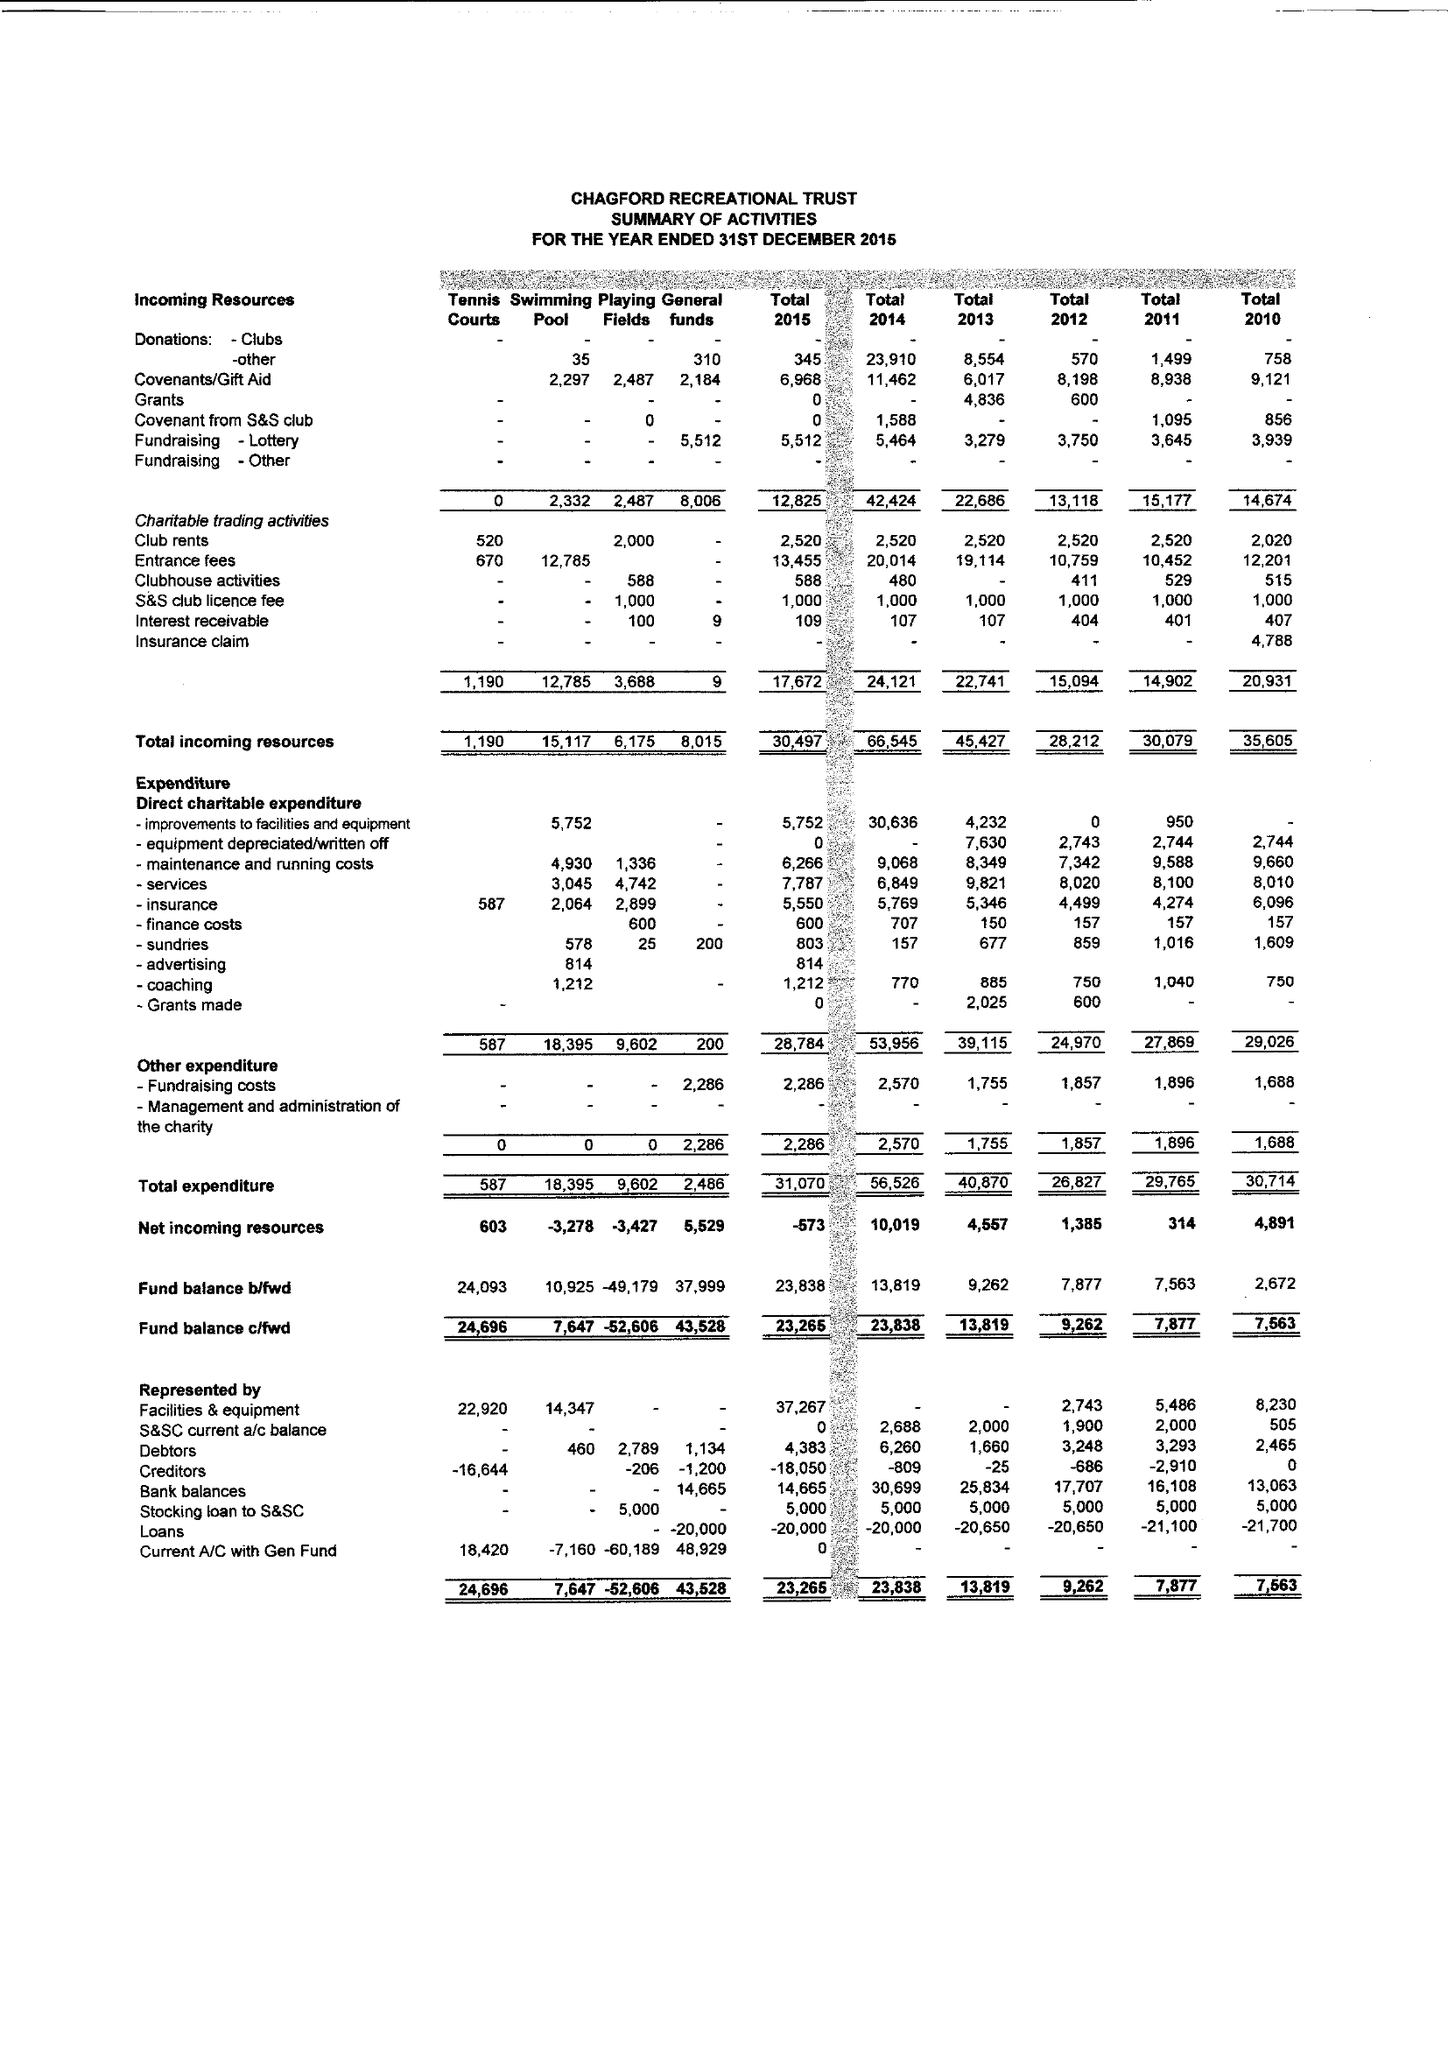What is the value for the charity_name?
Answer the question using a single word or phrase. Chagford Recreational Trust 